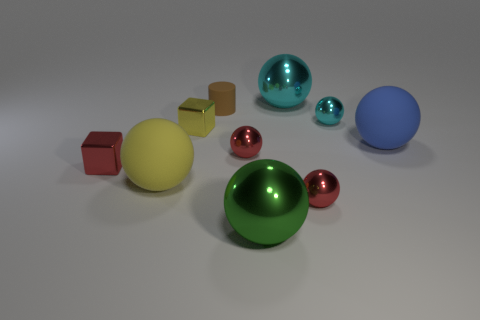Subtract all purple cubes. How many red balls are left? 2 Subtract all green spheres. How many spheres are left? 6 Subtract all green balls. How many balls are left? 6 Subtract 4 spheres. How many spheres are left? 3 Subtract all green spheres. Subtract all gray cylinders. How many spheres are left? 6 Subtract all big brown blocks. Subtract all yellow metallic blocks. How many objects are left? 9 Add 2 cubes. How many cubes are left? 4 Add 1 blue rubber balls. How many blue rubber balls exist? 2 Subtract 0 purple spheres. How many objects are left? 10 Subtract all blocks. How many objects are left? 8 